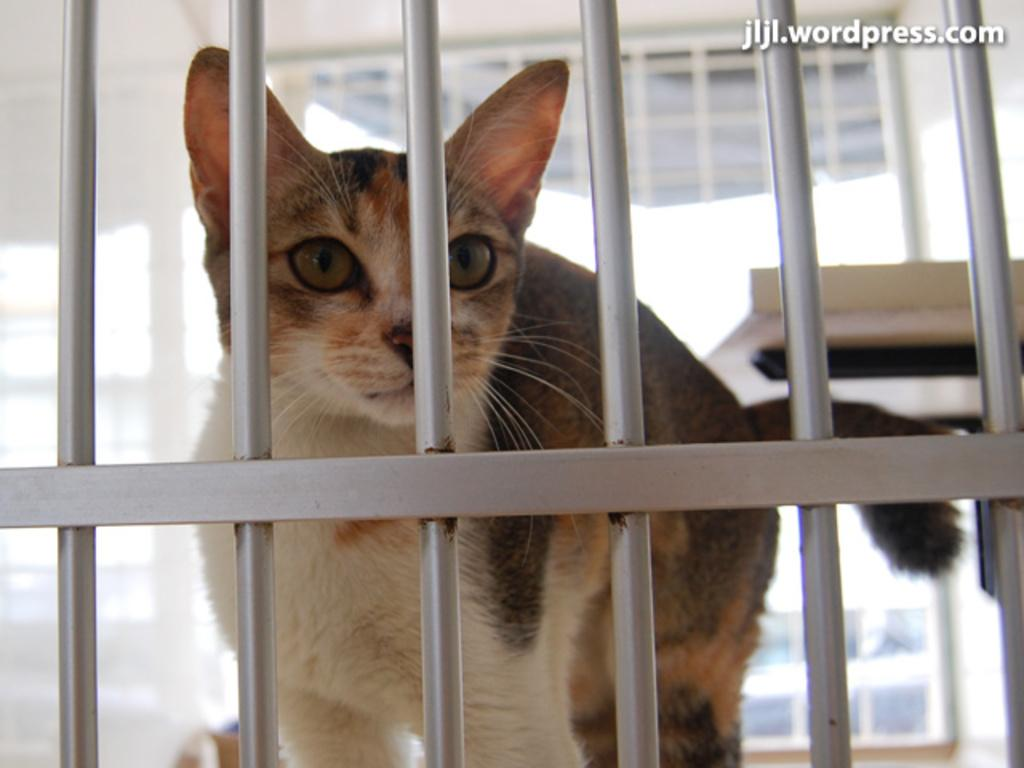What is the main subject in the center of the image? There is a cat in the center of the image. What can be seen in the background of the image? There are grills in the background of the image. What is located at the top of the image? There is a window at the top of the image. What is on the right side of the image? There is a table on the right side of the image. What type of rifle is the cat holding in the image? There is no rifle present in the image; the cat is not holding any object. 